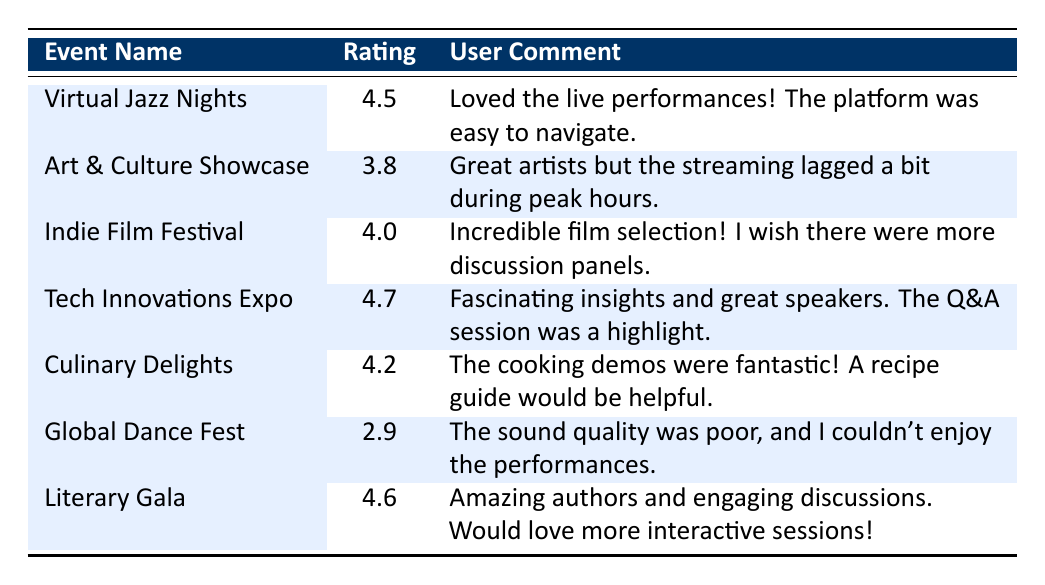What is the highest rating among the events? The table lists the ratings for each event. I can see that the Tech Innovations Expo has the highest rating of 4.7.
Answer: 4.7 How many events received a rating of 4.0 or higher? By reviewing the ratings, the events with ratings of 4.0 or higher are Virtual Jazz Nights (4.5), Indie Film Festival (4.0), Tech Innovations Expo (4.7), Culinary Delights (4.2), and Literary Gala (4.6). This totals to 5 events.
Answer: 5 What was the user comment for the Global Dance Fest? Looking at the table, the comment for the Global Dance Fest is "The sound quality was poor, and I couldn't enjoy the performances."
Answer: The sound quality was poor, and I couldn't enjoy the performances What is the difference in ratings between the top-rated event and the lowest-rated event? The highest-rated event is Tech Innovations Expo with a rating of 4.7 and the lowest-rated event is Global Dance Fest with a rating of 2.9. So, the difference is 4.7 - 2.9 = 1.8.
Answer: 1.8 Did the Art & Culture Showcase receive a rating above 4.0? Checking the rating for Art & Culture Showcase, it received a rating of 3.8, which is below 4.0.
Answer: No Which event had a comment suggesting the addition of more interactive sessions? The comment related to having more interactive sessions is from the Literary Gala, which states "Would love more interactive sessions!"
Answer: Literary Gala What is the average rating of all the events? First, I will sum all the ratings: 4.5 + 3.8 + 4.0 + 4.7 + 4.2 + 2.9 + 4.6 = 28.7. Then, divide by the number of events, which is 7: 28.7 / 7 = 4.1.
Answer: 4.1 Was there any comment that mentioned issues with streaming? Yes, the Art & Culture Showcase's comment mentions "the streaming lagged a bit during peak hours."
Answer: Yes What rating did the user give to the Culinary Delights event? The rating provided for Culinary Delights is 4.2 as stated in the table.
Answer: 4.2 